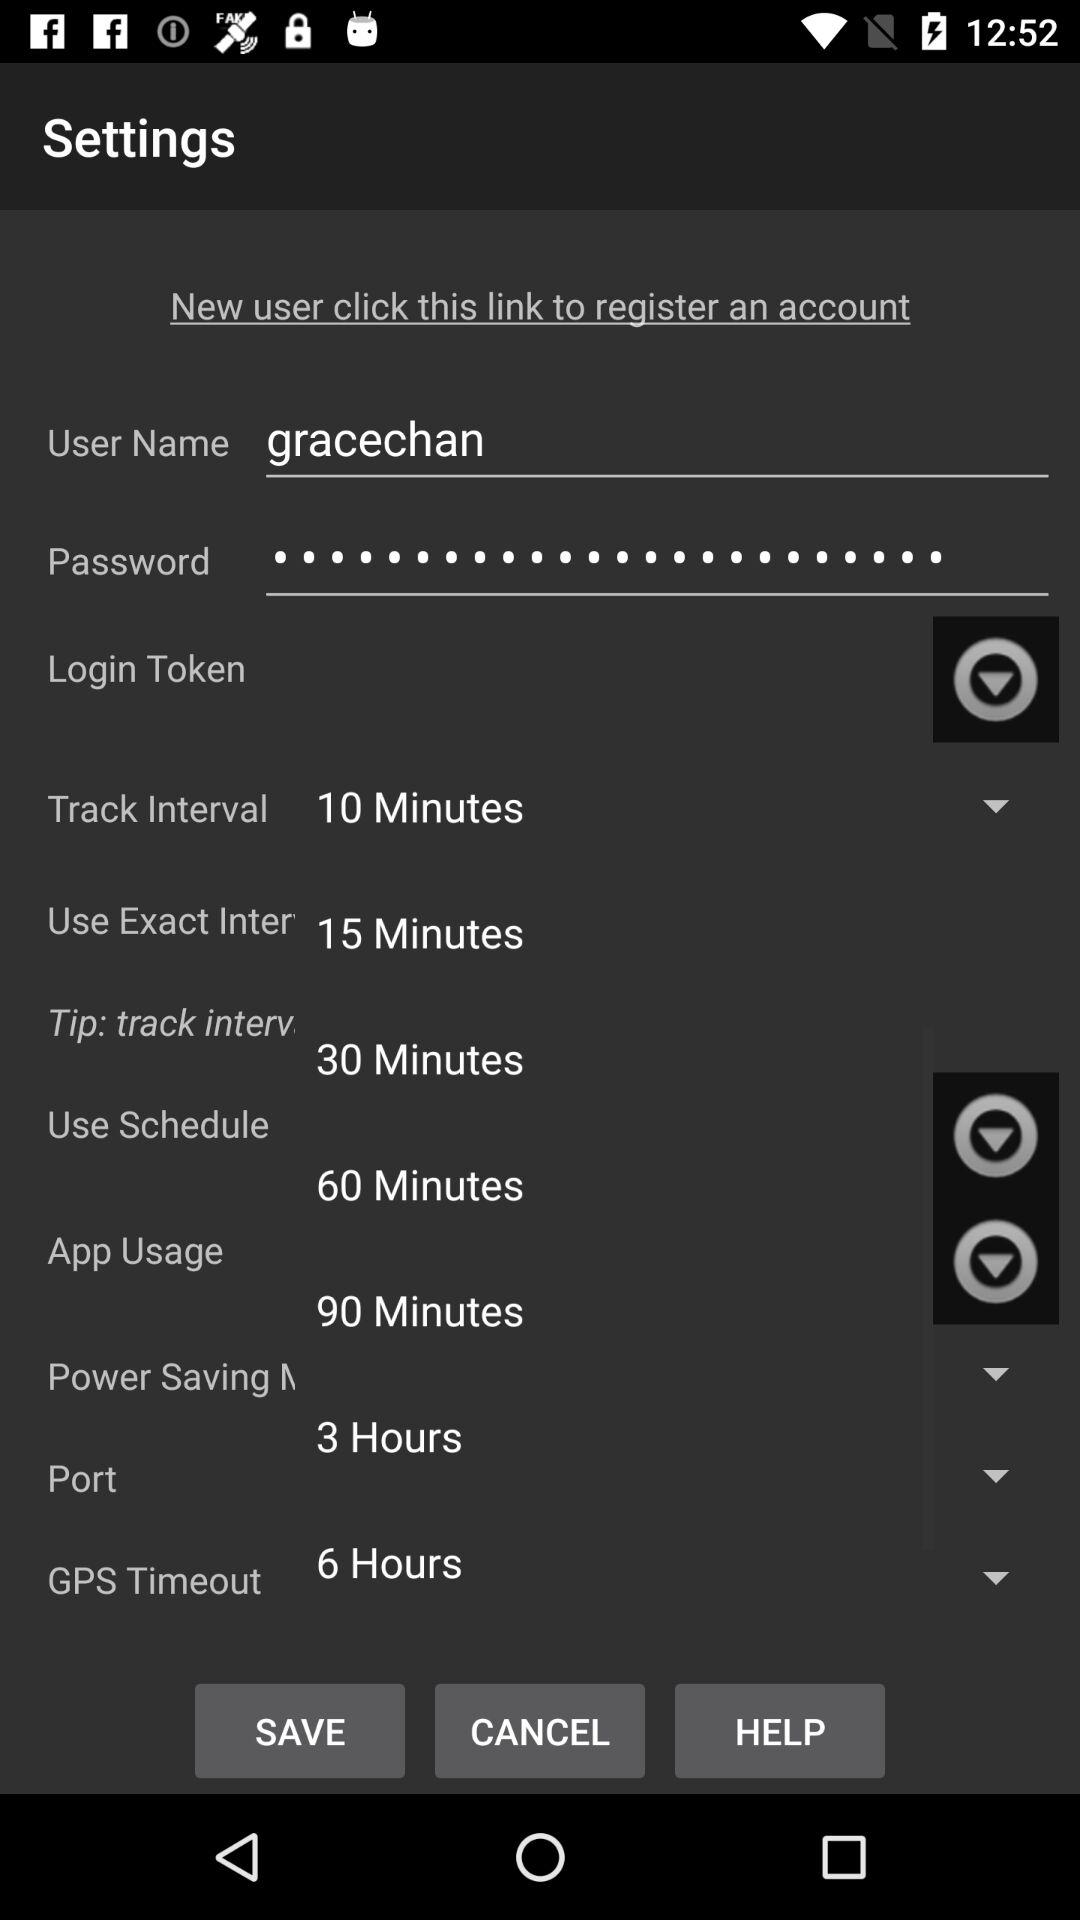What is the username? The username is "gracechan". 